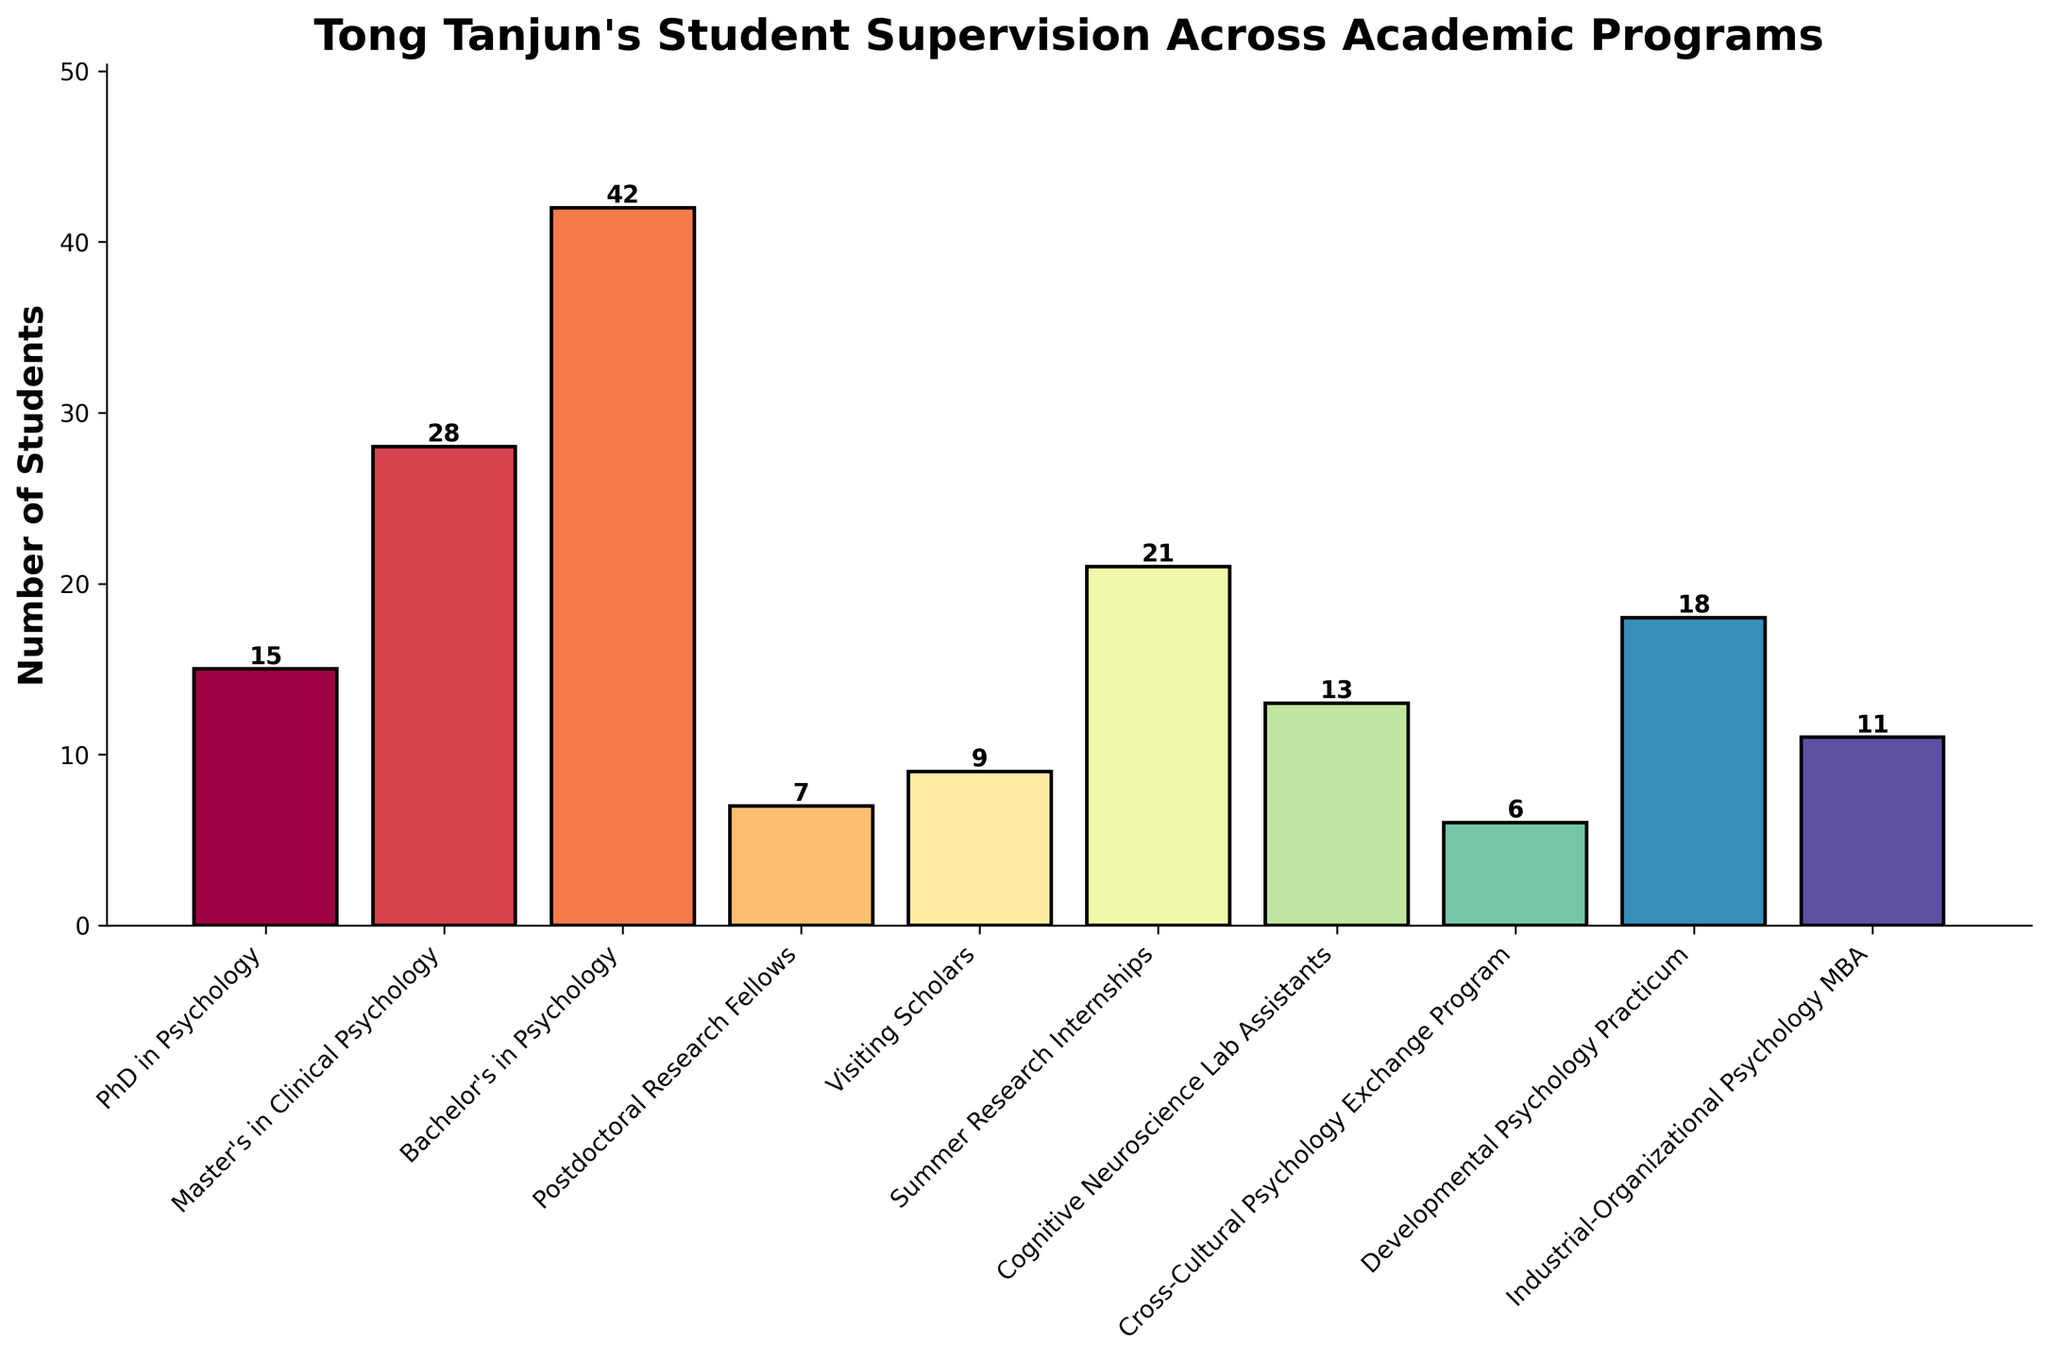What program supervises the most students? By glancing at the heights of the bars, we see the tallest bar corresponds to the Bachelor's in Psychology program.
Answer: Bachelor's in Psychology What is the total number of students supervised by Tong Tanjun across all programs? Summing the number of students in each program: 15 + 28 + 42 + 7 + 9 + 21 + 13 + 6 + 18 + 11 = 170
Answer: 170 Which program has more students, PhD in Psychology or Summer Research Internships? By how many? The bar for Summer Research Internships appears higher than for PhD in Psychology. For the exact difference: 21 - 15 = 6
Answer: Summer Research Internships by 6 How does the number of students in the Master’s in Clinical Psychology program compare to the Developmental Psychology Practicum? The bar for Master's in Clinical Psychology is taller than that for Developmental Psychology Practicum. The exact numbers are 28 vs. 18, making Master's in Clinical Psychology have more students.
Answer: Master's in Clinical Psychology What is the average number of students supervised per program? Sum the total number of students (170) and divide by the number of programs (10), 170 / 10 = 17
Answer: 17 Which programs have fewer than 10 students? The bars that are lower than the 10-mark on the y-axis represent the Postdoctoral Research Fellows and Cross-Cultural Psychology Exchange Program.
Answer: Postdoctoral Research Fellows, Cross-Cultural Psychology Exchange Program What is the difference in the number of students between the Cognitive Neuroscience Lab Assistants and the Visiting Scholars? The Cognitive Neuroscience Lab Assistants have 13 students and Visiting Scholars have 9. The difference between them is 13 - 9 = 4
Answer: 4 Rank the programs from highest to lowest based on the number of students supervised. The order can be determined by the height of the bars: Bachelor's in Psychology (42), Master's in Clinical Psychology (28), Summer Research Internships (21), Developmental Psychology Practicum (18), PhD in Psychology (15), Cognitive Neuroscience Lab Assistants (13), Industrial-Organizational Psychology MBA (11), Visiting Scholars (9), Postdoctoral Research Fellows (7), Cross-Cultural Psychology Exchange Program (6).
Answer: Bachelor's in Psychology > Master's in Clinical Psychology > Summer Research Internships > Developmental Psychology Practicum > PhD in Psychology > Cognitive Neuroscience Lab Assistants > Industrial-Organizational Psychology MBA > Visiting Scholars > Postdoctoral Research Fellows > Cross-Cultural Psychology Exchange Program If Tong Tanjun decides to supervise 5 more students in PhD in Psychology, how does the ranking change? Adding 5 to the PhD in Psychology program makes it 15 + 5 = 20. This new total would place it between Developmental Psychology Practicum and Summer Research Internships: Bachelor's in Psychology (42), Master's in Clinical Psychology (28), Summer Research Internships (21), PhD in Psychology (20), Developmental Psychology Practicum (18).
Answer: It moves to the 4th position How many students does Tong Tanjun supervise in programs that have more than 20 students each? Programs with more than 20 students are: Bachelor's in Psychology (42), Master's in Clinical Psychology (28), Summer Research Internships (21). Adding these gives 42 + 28 + 21 = 91
Answer: 91 